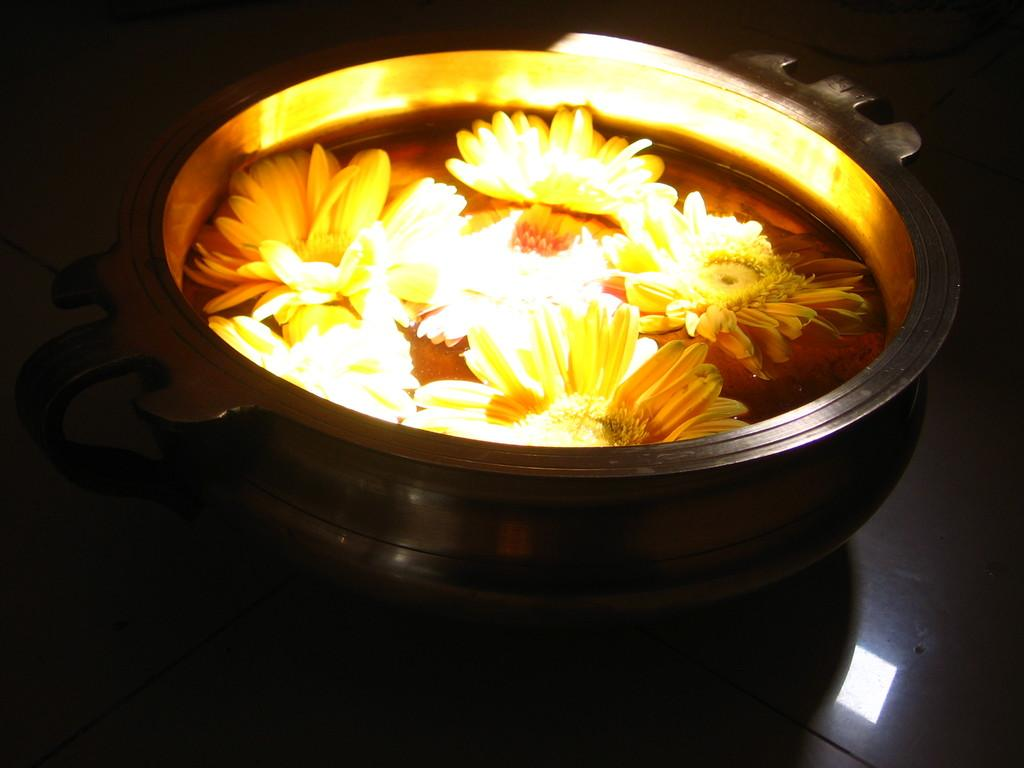What type of plants can be seen in the image? There are flowers in the image. What is the container holding in the image? There is a container with water in the image. What surface is visible in the image? There is a floor visible in the image. Where is the goat sitting in the image? There is no goat present in the image. What type of furniture is the goat sitting on in the image? Since there is no goat in the image, it is not possible to determine what type of furniture it might be sitting on. 